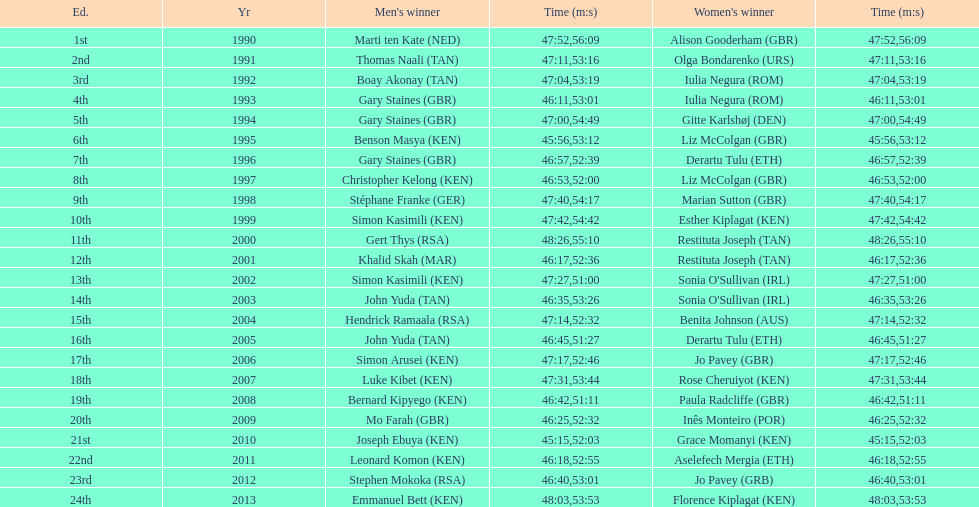What is the number of times, between 1990 and 2013, for britain not to win the men's or women's bupa great south run? 13. 